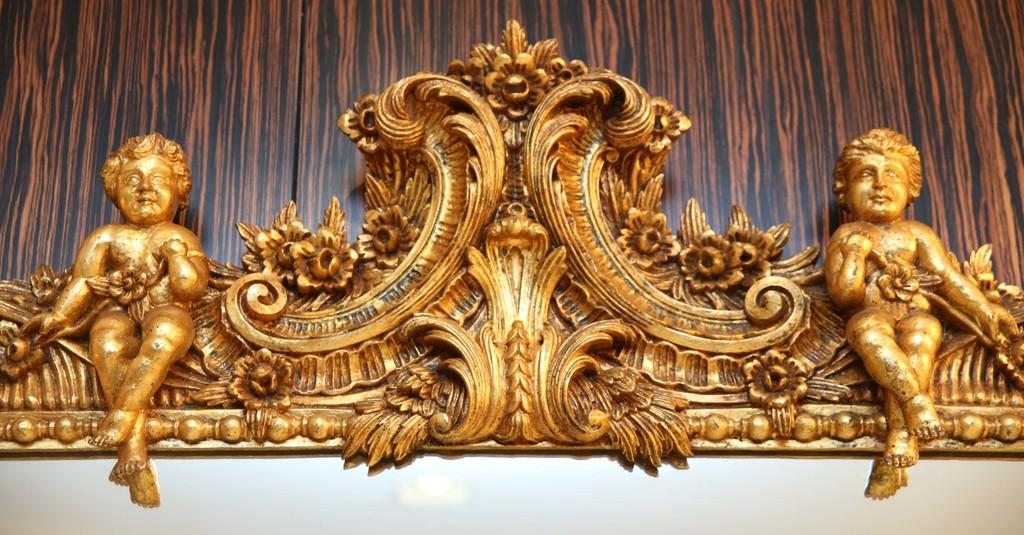What is the main subject of the image? There is a sculpture in the image. What can be seen behind the sculpture? The background of the image appears to be a wall. What design is featured on the rock in the image? There is no rock present in the image; it only features a sculpture and a wall. What is the value of the sculpture in the image? The value of the sculpture cannot be determined from the image alone. 